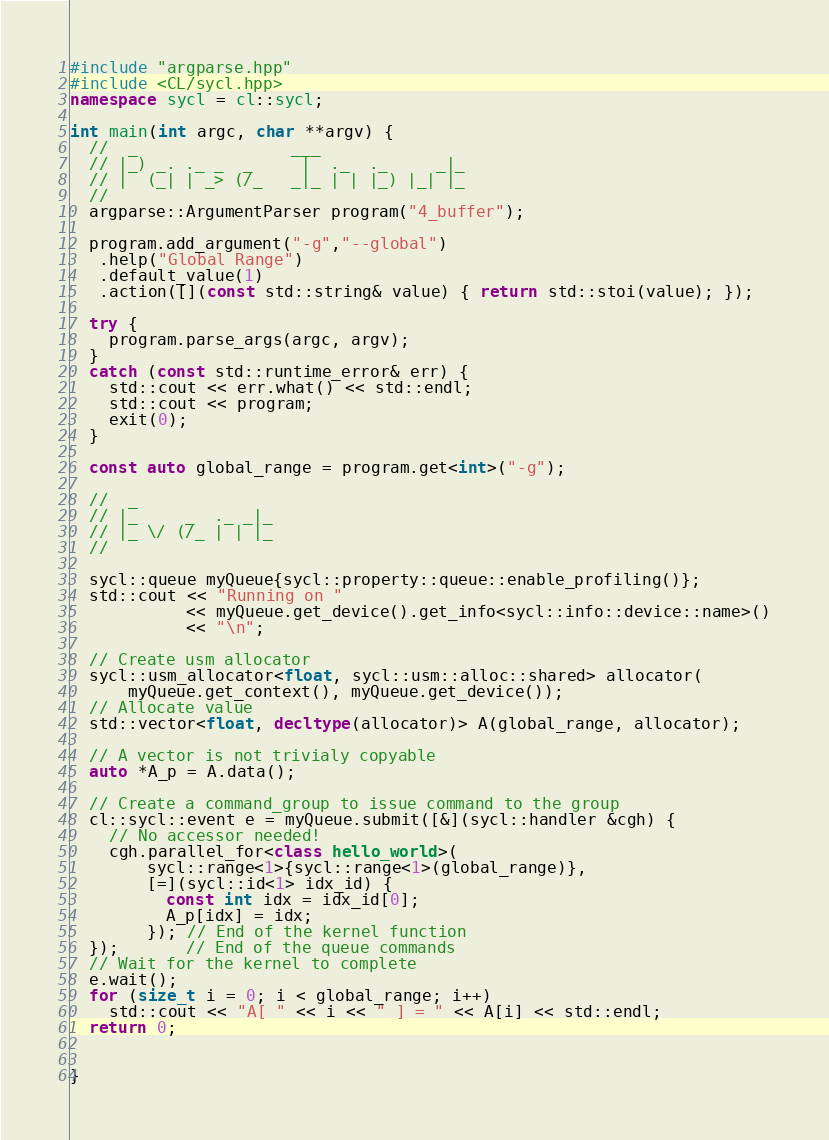Convert code to text. <code><loc_0><loc_0><loc_500><loc_500><_C++_>#include "argparse.hpp"
#include <CL/sycl.hpp>
namespace sycl = cl::sycl;

int main(int argc, char **argv) {
  //  _                ___
  // |_) _. ._ _  _     |  ._  ._     _|_
  // |  (_| | _> (/_   _|_ | | |_) |_| |_
  //
  argparse::ArgumentParser program("4_buffer");

  program.add_argument("-g","--global")
   .help("Global Range")
   .default_value(1)
   .action([](const std::string& value) { return std::stoi(value); });

  try {
    program.parse_args(argc, argv);
  }
  catch (const std::runtime_error& err) {
    std::cout << err.what() << std::endl;
    std::cout << program;
    exit(0);
  }

  const auto global_range = program.get<int>("-g");

  //  _               
  // |_     _  ._ _|_ 
  // |_ \/ (/_ | | |_ 
  //                  

  sycl::queue myQueue{sycl::property::queue::enable_profiling()};
  std::cout << "Running on "
            << myQueue.get_device().get_info<sycl::info::device::name>()
            << "\n";

  // Create usm allocator
  sycl::usm_allocator<float, sycl::usm::alloc::shared> allocator(
      myQueue.get_context(), myQueue.get_device());
  // Allocate value
  std::vector<float, decltype(allocator)> A(global_range, allocator);
  
  // A vector is not trivialy copyable
  auto *A_p = A.data();

  // Create a command_group to issue command to the group
  cl::sycl::event e = myQueue.submit([&](sycl::handler &cgh) {
    // No accessor needed!
    cgh.parallel_for<class hello_world>(
        sycl::range<1>{sycl::range<1>(global_range)},
        [=](sycl::id<1> idx_id) {
          const int idx = idx_id[0];
          A_p[idx] = idx;
        }); // End of the kernel function
  });       // End of the queue commands
  // Wait for the kernel to complete
  e.wait();
  for (size_t i = 0; i < global_range; i++)
    std::cout << "A[ " << i << " ] = " << A[i] << std::endl;
  return 0;


}
</code> 